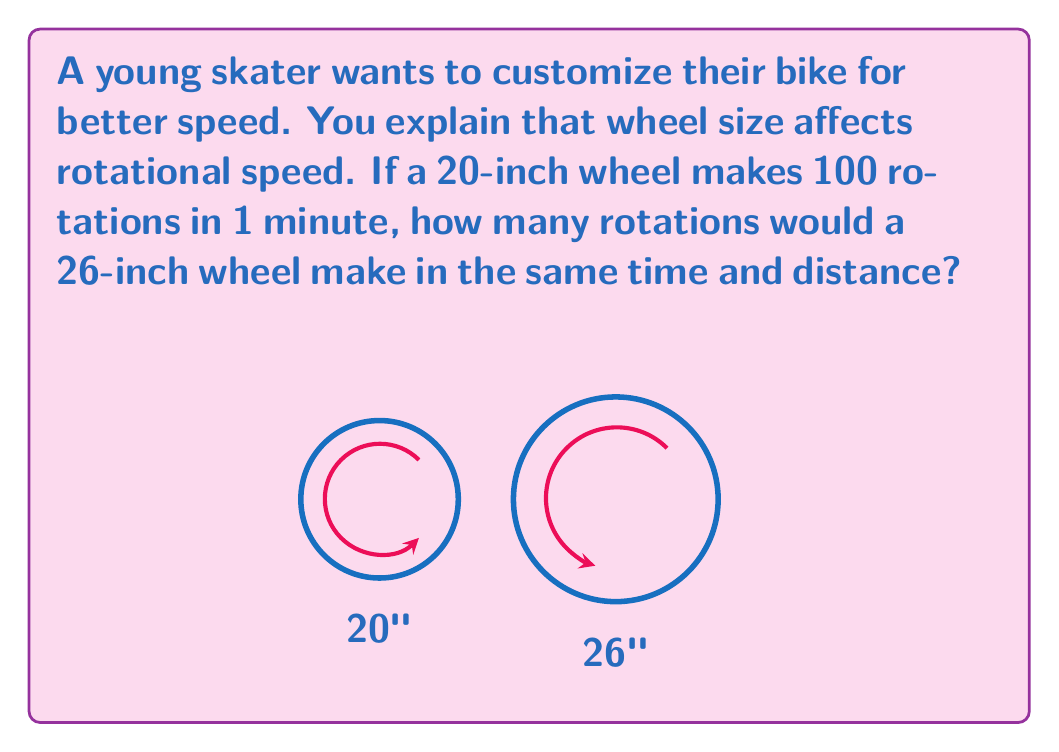Could you help me with this problem? Let's approach this step-by-step:

1) First, we need to understand the relationship between wheel size and rotations. For the same distance traveled, a larger wheel will make fewer rotations than a smaller wheel.

2) Let's define some variables:
   $d_1 = 20$ inches (diameter of smaller wheel)
   $d_2 = 26$ inches (diameter of larger wheel)
   $r_1 = 100$ rotations (rotations of smaller wheel)
   $r_2 =$ rotations of larger wheel (what we're solving for)

3) The distance traveled is the same for both wheels. We can express this as:
   $$\pi d_1 r_1 = \pi d_2 r_2$$

4) Substituting our known values:
   $$\pi(20)(100) = \pi(26)r_2$$

5) The $\pi$ cancels out on both sides:
   $$2000 = 26r_2$$

6) Solving for $r_2$:
   $$r_2 = \frac{2000}{26} \approx 76.92$$

7) Since we can't have a fraction of a rotation, we round to the nearest whole number:
   $$r_2 = 77$$

Therefore, the 26-inch wheel would make 77 rotations in the same time and distance.
Answer: 77 rotations 